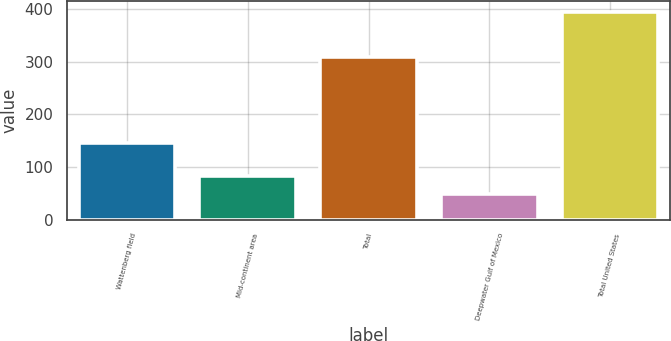<chart> <loc_0><loc_0><loc_500><loc_500><bar_chart><fcel>Wattenberg field<fcel>Mid-continent area<fcel>Total<fcel>Deepwater Gulf of Mexico<fcel>Total United States<nl><fcel>146<fcel>83.6<fcel>308<fcel>49<fcel>395<nl></chart> 